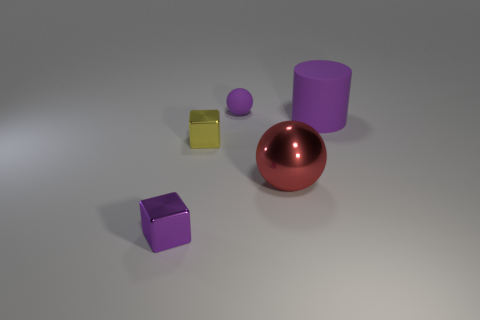There is a purple object that is left of the purple rubber cylinder and behind the tiny purple metal thing; what material is it made of?
Your answer should be compact. Rubber. There is a matte object that is on the right side of the small purple object that is behind the purple rubber object on the right side of the big ball; what color is it?
Make the answer very short. Purple. What color is the metallic thing that is the same size as the purple cylinder?
Give a very brief answer. Red. Do the cylinder and the ball behind the big purple matte cylinder have the same color?
Provide a short and direct response. Yes. There is a small cube that is behind the purple object that is left of the tiny yellow shiny block; what is it made of?
Provide a succinct answer. Metal. What number of objects are behind the red ball and right of the yellow metal block?
Ensure brevity in your answer.  2. What number of other objects are the same size as the purple rubber cylinder?
Offer a terse response. 1. There is a small thing that is in front of the red thing; is it the same shape as the small thing that is behind the yellow metal object?
Offer a terse response. No. There is a big purple matte thing; are there any big matte cylinders right of it?
Make the answer very short. No. What is the color of the other small object that is the same shape as the red shiny thing?
Provide a succinct answer. Purple. 